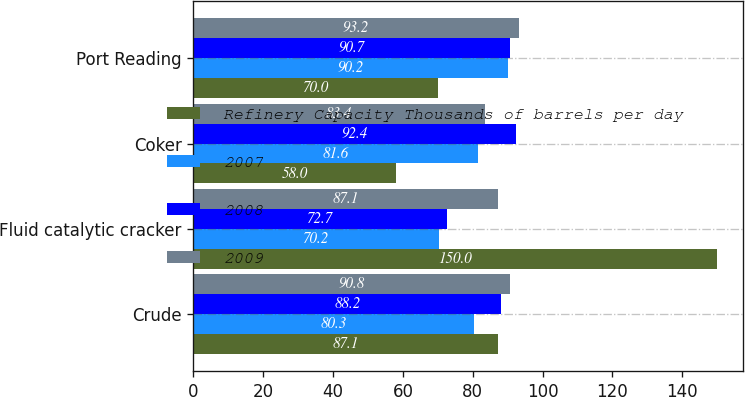Convert chart to OTSL. <chart><loc_0><loc_0><loc_500><loc_500><stacked_bar_chart><ecel><fcel>Crude<fcel>Fluid catalytic cracker<fcel>Coker<fcel>Port Reading<nl><fcel>Refinery Capacity Thousands of barrels per day<fcel>87.1<fcel>150<fcel>58<fcel>70<nl><fcel>2007<fcel>80.3<fcel>70.2<fcel>81.6<fcel>90.2<nl><fcel>2008<fcel>88.2<fcel>72.7<fcel>92.4<fcel>90.7<nl><fcel>2009<fcel>90.8<fcel>87.1<fcel>83.4<fcel>93.2<nl></chart> 